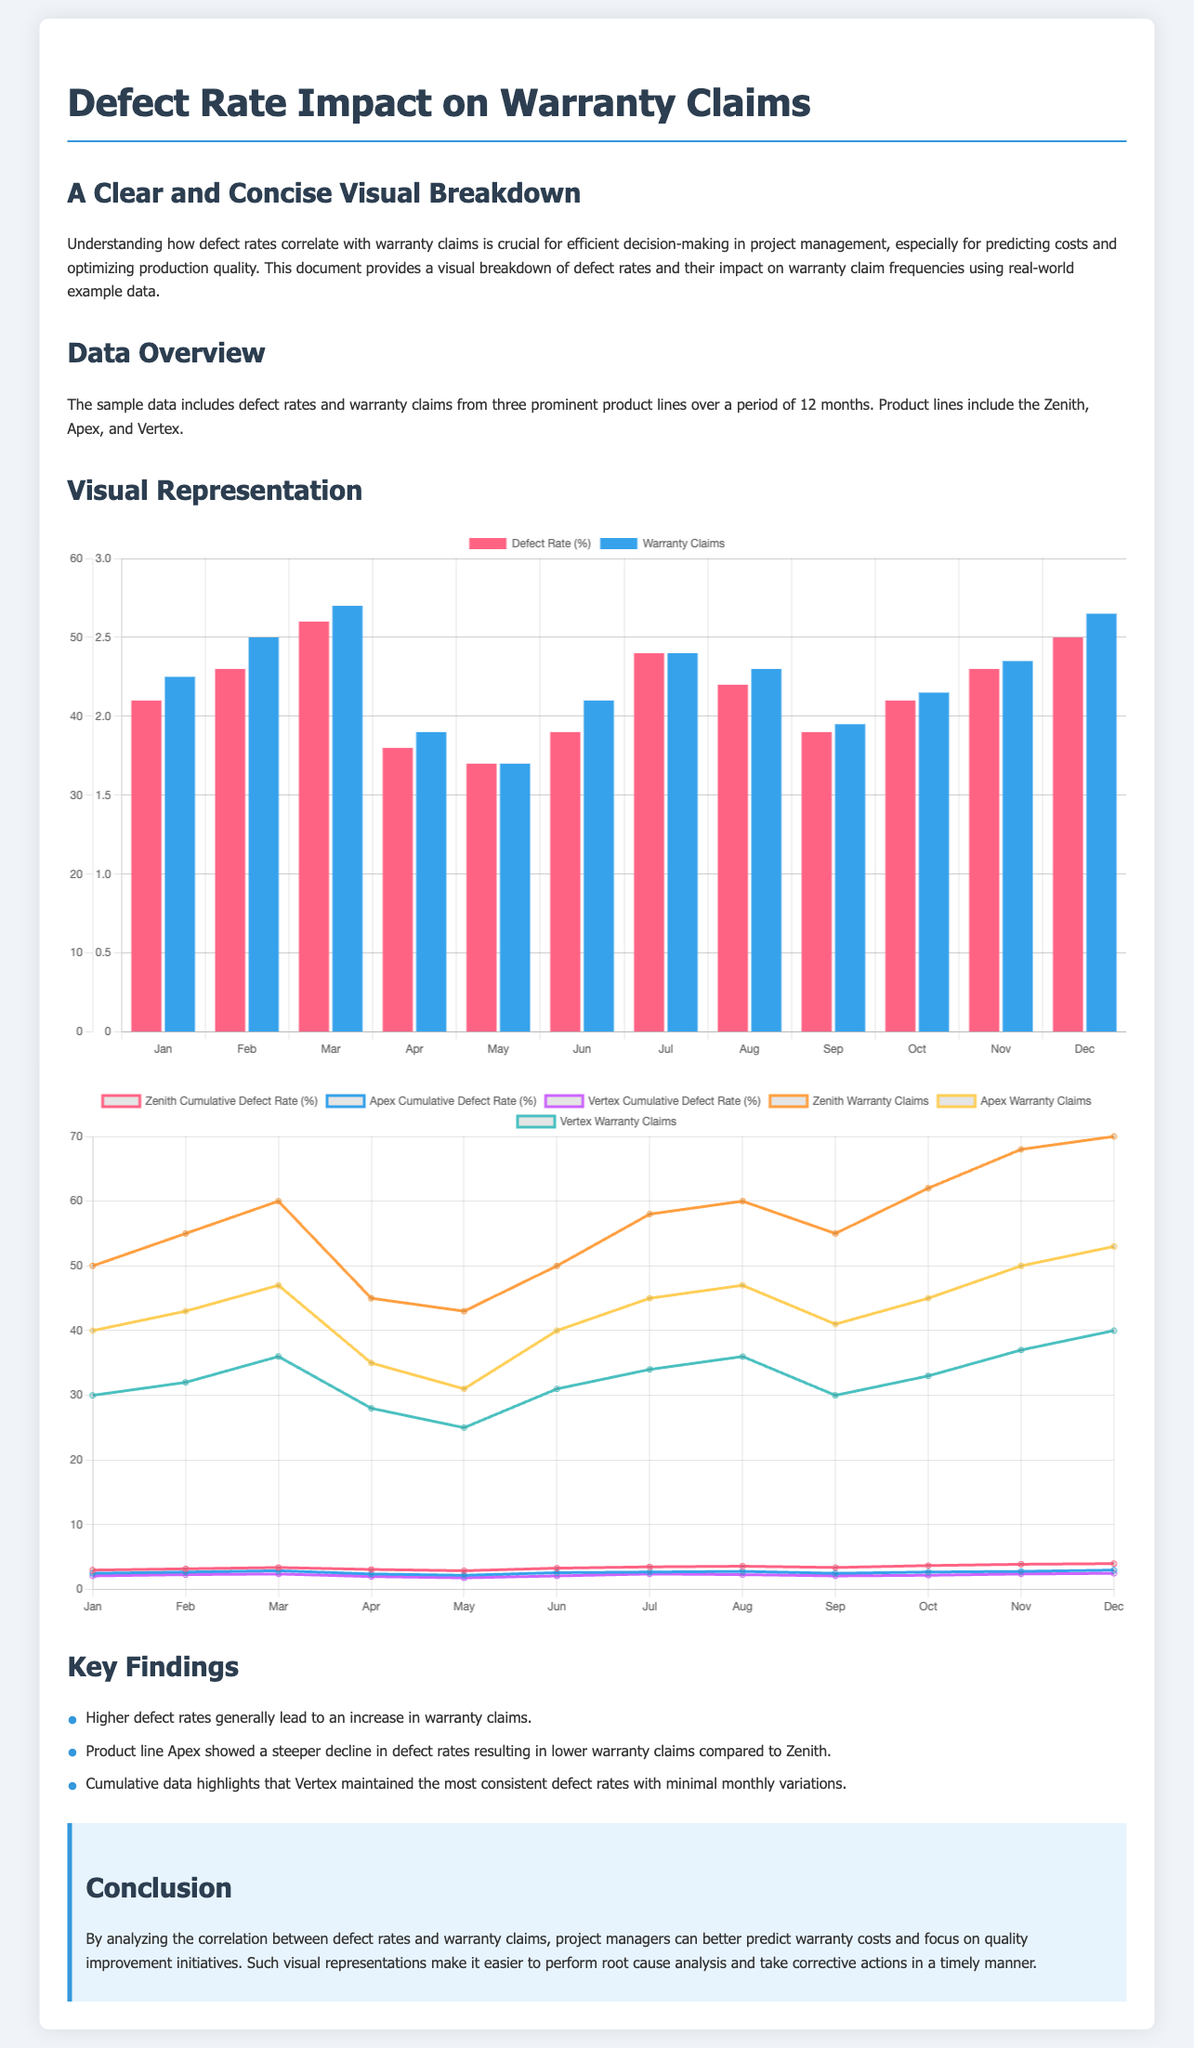what is the highest defect rate recorded? The document indicates that the highest defect rate recorded was in March, which is 2.6%.
Answer: 2.6% what is the warranty claims count for the month of April? The warranty claims count for April is listed on the graph as 38.
Answer: 38 which product line has the lowest cumulative defect rate? By analyzing the cumulative defect rates presented, Vertex displays the lowest cumulative defect rate.
Answer: Vertex what trend does the Apex product line demonstrate in terms of warranty claims? The Apex product line shows a trend of decreasing warranty claims, particularly in the latter months.
Answer: Decreasing how many product lines are represented in the data? The document clearly states that there are three product lines represented: Zenith, Apex, and Vertex.
Answer: Three what is the cumulative defect rate for Zenith in December? The cumulative defect rate for Zenith is shown to be 4.0% in December.
Answer: 4.0% which month had the lowest number of warranty claims? According to the graph, the month with the lowest warranty claims was in April, with a total of 38 claims.
Answer: April what color represents warranty claims in the monthly chart? The color used to represent warranty claims in the monthly chart is blue.
Answer: Blue how many total months are included in the sample data? The sample data includes a total of 12 months.
Answer: 12 